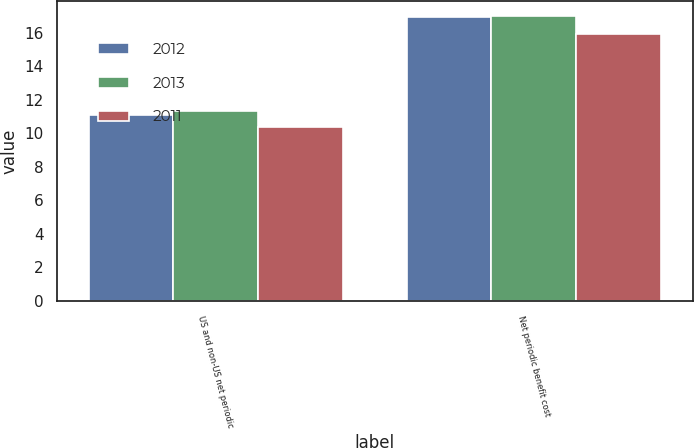<chart> <loc_0><loc_0><loc_500><loc_500><stacked_bar_chart><ecel><fcel>US and non-US net periodic<fcel>Net periodic benefit cost<nl><fcel>2012<fcel>11.1<fcel>16.9<nl><fcel>2013<fcel>11.3<fcel>17<nl><fcel>2011<fcel>10.4<fcel>15.9<nl></chart> 